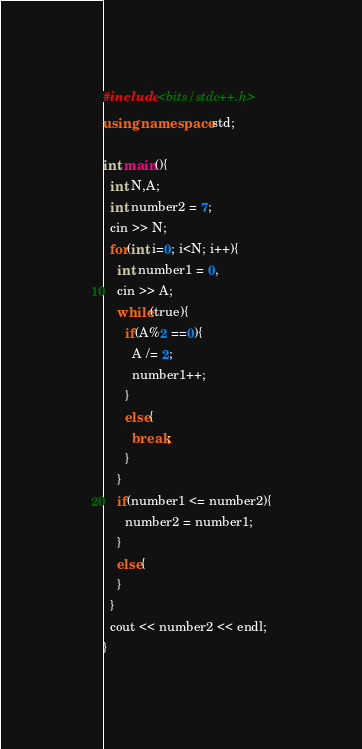<code> <loc_0><loc_0><loc_500><loc_500><_C++_>#include <bits/stdc++.h>
using namespace std;

int main(){
  int N,A;
  int number2 = 7;
  cin >> N;
  for(int i=0; i<N; i++){
    int number1 = 0,
    cin >> A;
    while(true){
      if(A%2 ==0){
        A /= 2;
        number1++;
      }
      else{
        break;
      }
    }
    if(number1 <= number2){
      number2 = number1;
    }
    else{ 
    }
  }
  cout << number2 << endl;
}</code> 